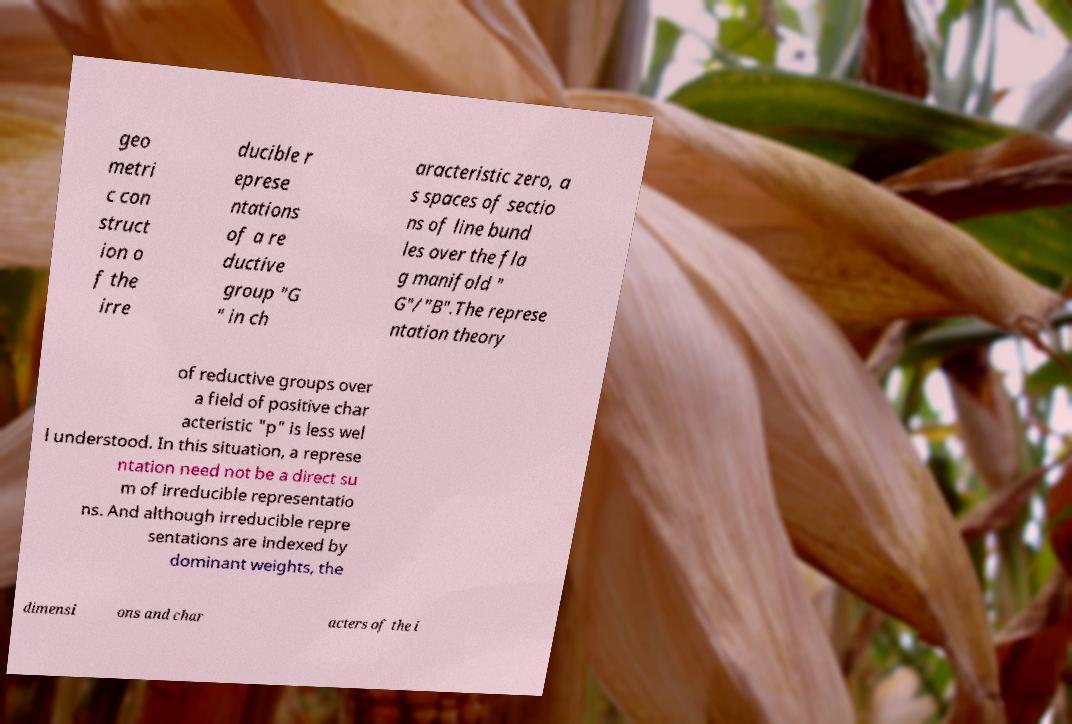For documentation purposes, I need the text within this image transcribed. Could you provide that? geo metri c con struct ion o f the irre ducible r eprese ntations of a re ductive group "G " in ch aracteristic zero, a s spaces of sectio ns of line bund les over the fla g manifold " G"/"B".The represe ntation theory of reductive groups over a field of positive char acteristic "p" is less wel l understood. In this situation, a represe ntation need not be a direct su m of irreducible representatio ns. And although irreducible repre sentations are indexed by dominant weights, the dimensi ons and char acters of the i 